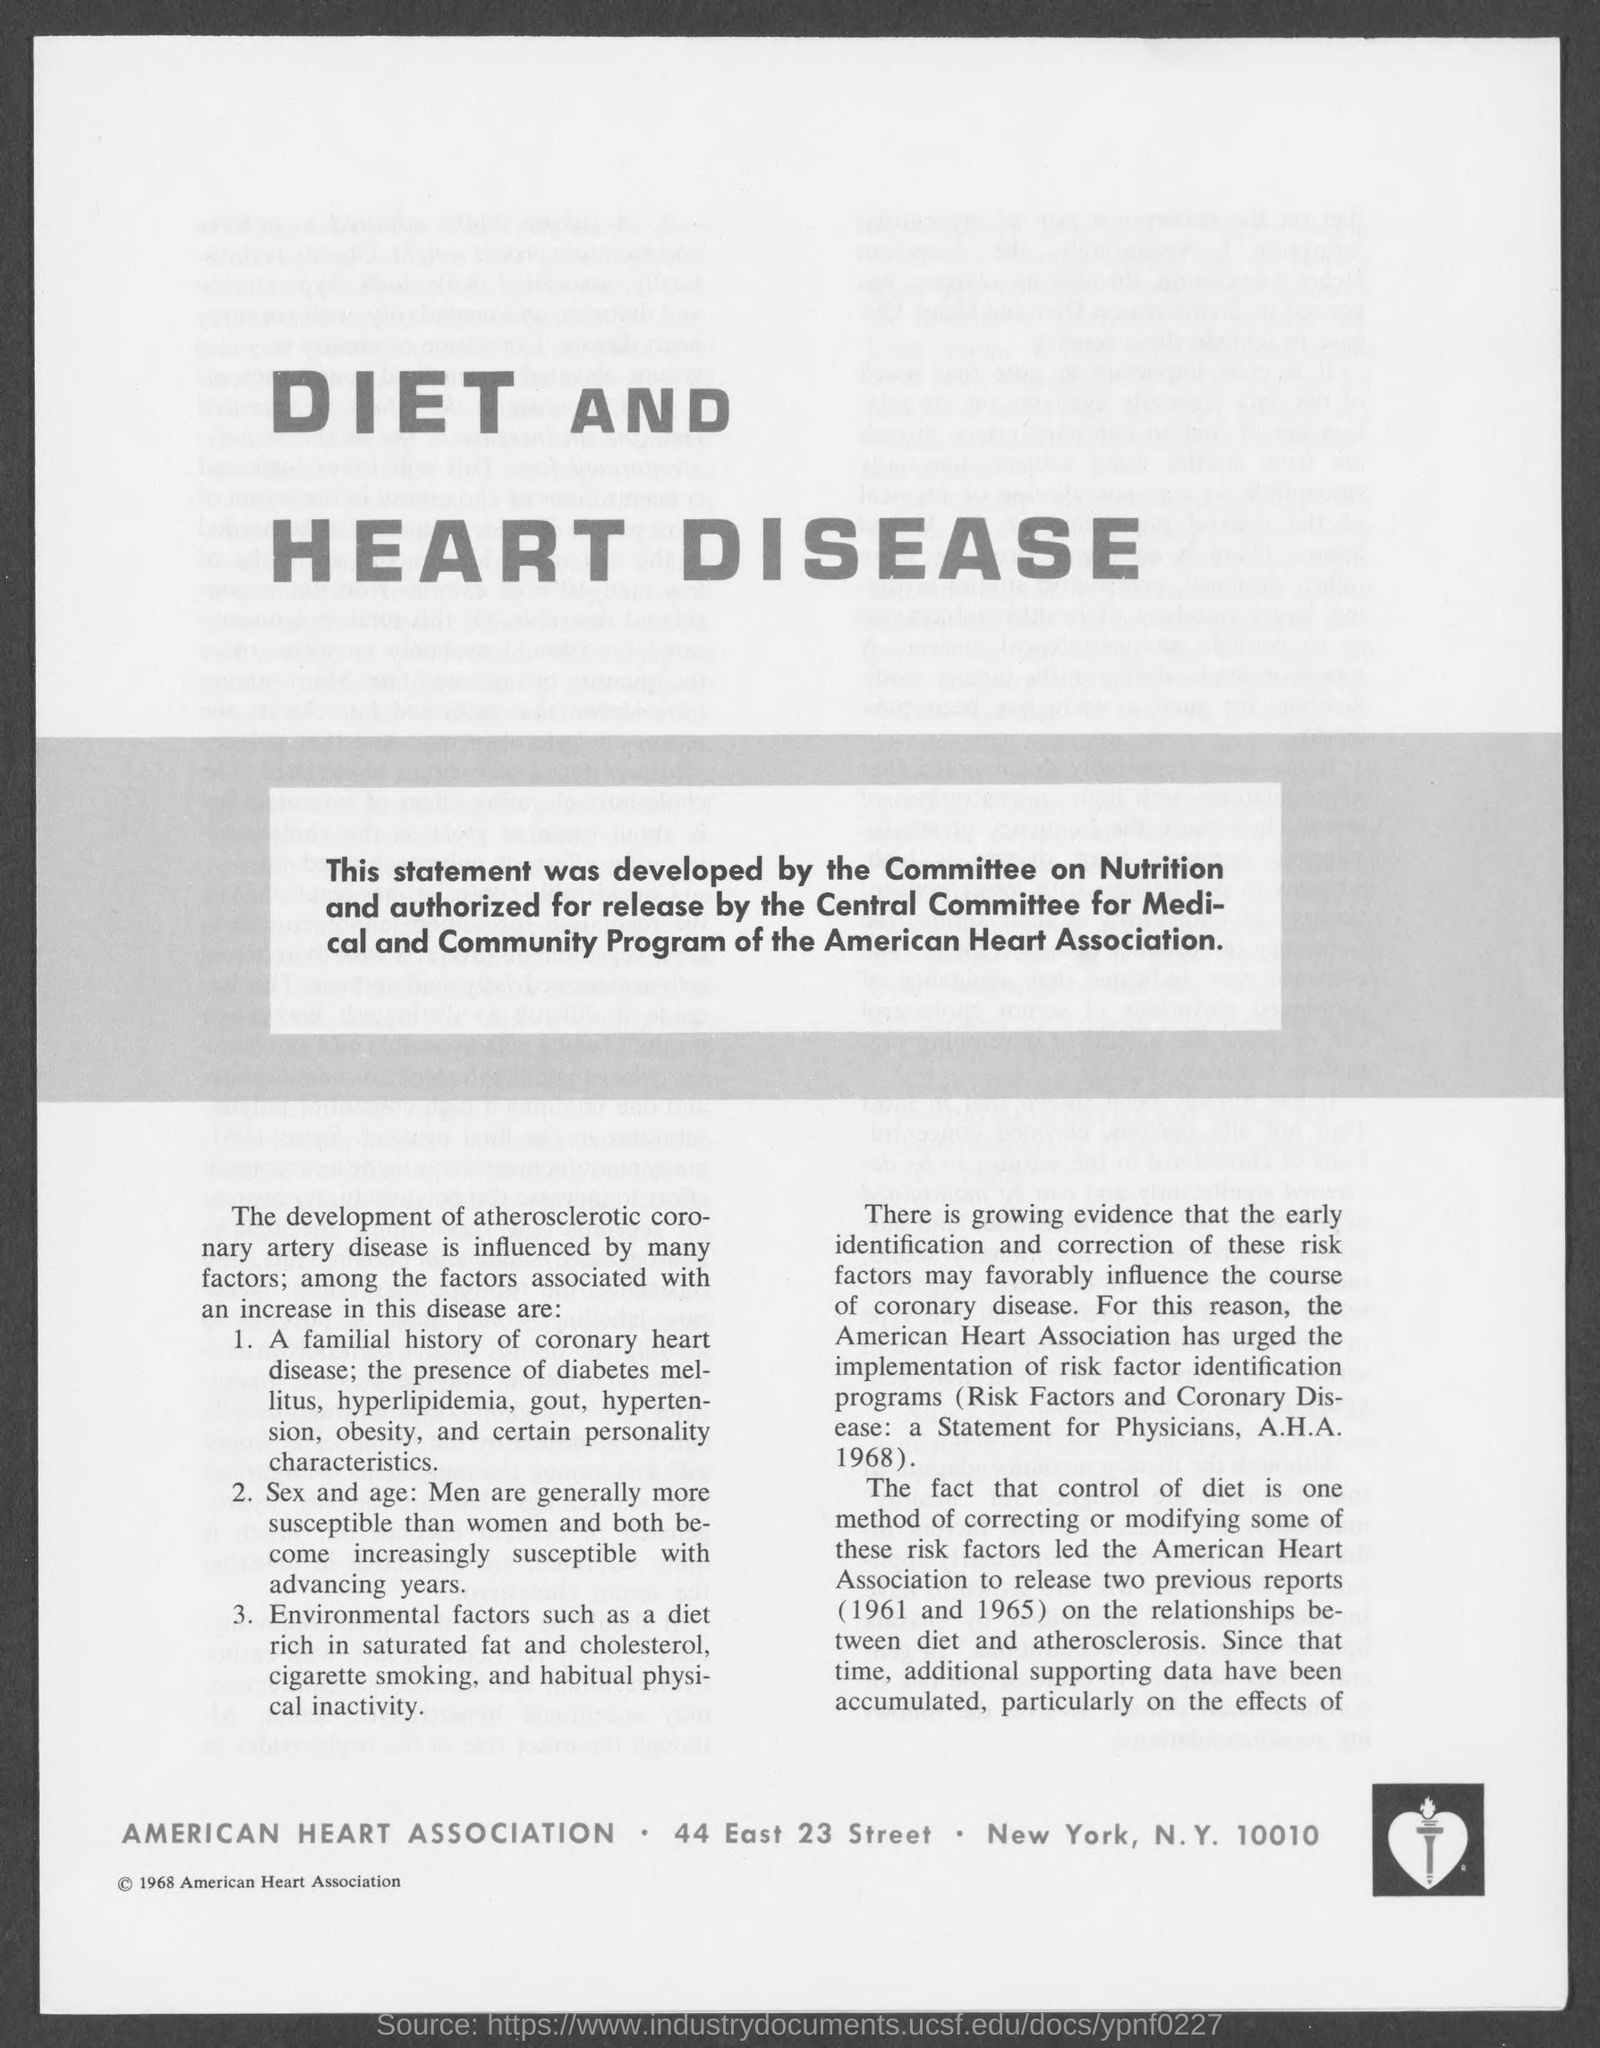Outline some significant characteristics in this image. The American Heart Association is located in New York City. 